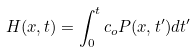Convert formula to latex. <formula><loc_0><loc_0><loc_500><loc_500>H ( x , t ) = \int _ { 0 } ^ { t } c _ { o } P ( x , t ^ { \prime } ) d t ^ { \prime }</formula> 